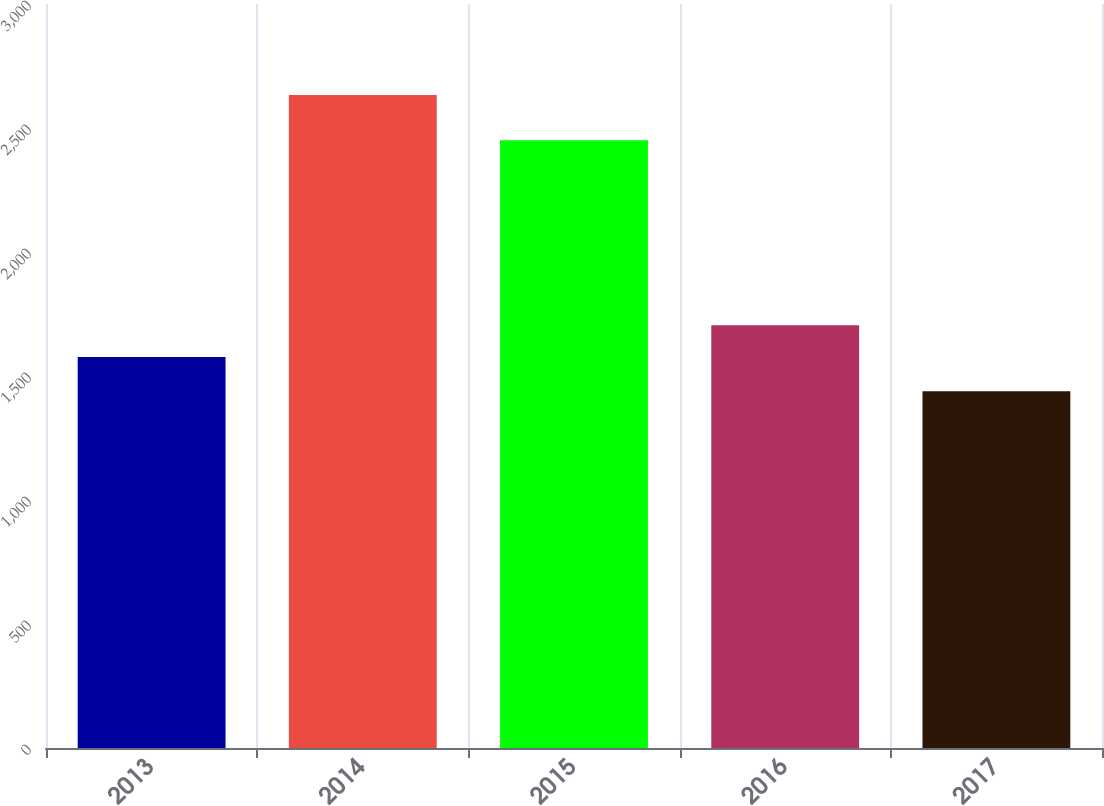Convert chart. <chart><loc_0><loc_0><loc_500><loc_500><bar_chart><fcel>2013<fcel>2014<fcel>2015<fcel>2016<fcel>2017<nl><fcel>1577<fcel>2633<fcel>2451<fcel>1705<fcel>1439<nl></chart> 